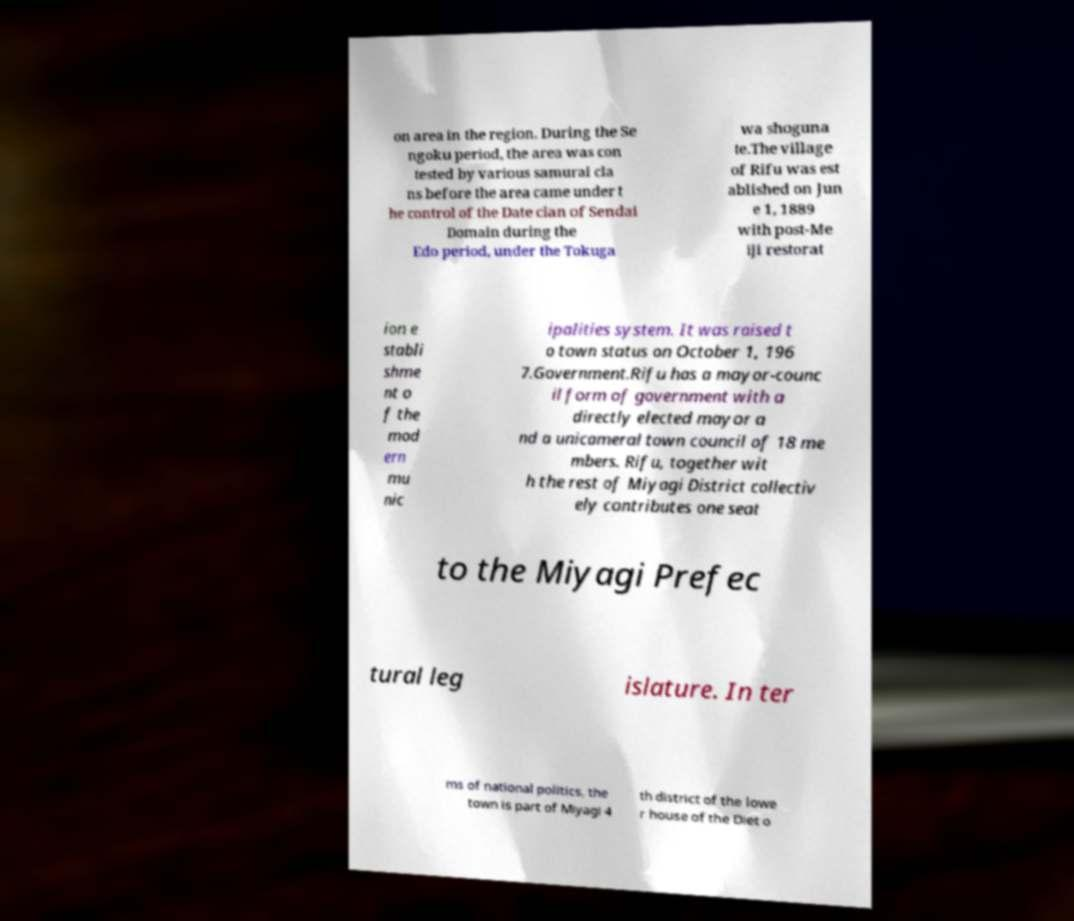Please identify and transcribe the text found in this image. on area in the region. During the Se ngoku period, the area was con tested by various samurai cla ns before the area came under t he control of the Date clan of Sendai Domain during the Edo period, under the Tokuga wa shoguna te.The village of Rifu was est ablished on Jun e 1, 1889 with post-Me iji restorat ion e stabli shme nt o f the mod ern mu nic ipalities system. It was raised t o town status on October 1, 196 7.Government.Rifu has a mayor-counc il form of government with a directly elected mayor a nd a unicameral town council of 18 me mbers. Rifu, together wit h the rest of Miyagi District collectiv ely contributes one seat to the Miyagi Prefec tural leg islature. In ter ms of national politics, the town is part of Miyagi 4 th district of the lowe r house of the Diet o 